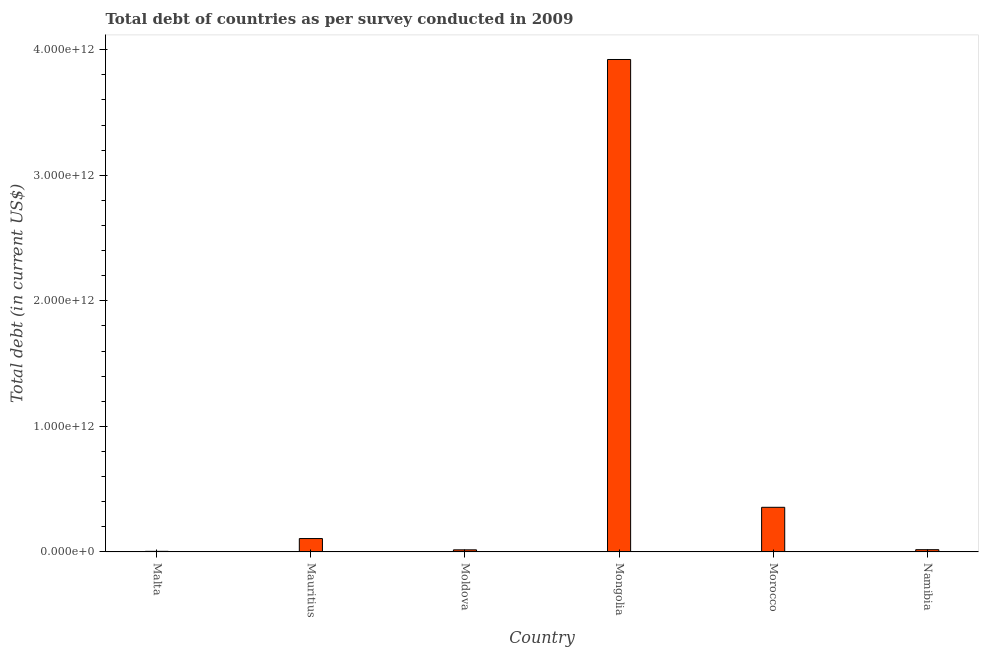What is the title of the graph?
Offer a terse response. Total debt of countries as per survey conducted in 2009. What is the label or title of the Y-axis?
Offer a terse response. Total debt (in current US$). What is the total debt in Morocco?
Keep it short and to the point. 3.56e+11. Across all countries, what is the maximum total debt?
Provide a succinct answer. 3.92e+12. Across all countries, what is the minimum total debt?
Provide a short and direct response. 4.78e+09. In which country was the total debt maximum?
Ensure brevity in your answer.  Mongolia. In which country was the total debt minimum?
Provide a succinct answer. Malta. What is the sum of the total debt?
Your response must be concise. 4.42e+12. What is the difference between the total debt in Malta and Mauritius?
Offer a terse response. -1.02e+11. What is the average total debt per country?
Ensure brevity in your answer.  7.37e+11. What is the median total debt?
Provide a succinct answer. 6.23e+1. In how many countries, is the total debt greater than 2200000000000 US$?
Make the answer very short. 1. What is the ratio of the total debt in Mauritius to that in Mongolia?
Offer a terse response. 0.03. Is the difference between the total debt in Mauritius and Namibia greater than the difference between any two countries?
Your answer should be compact. No. What is the difference between the highest and the second highest total debt?
Your answer should be compact. 3.57e+12. Is the sum of the total debt in Malta and Moldova greater than the maximum total debt across all countries?
Offer a terse response. No. What is the difference between the highest and the lowest total debt?
Provide a short and direct response. 3.92e+12. How many bars are there?
Provide a short and direct response. 6. How many countries are there in the graph?
Your answer should be very brief. 6. What is the difference between two consecutive major ticks on the Y-axis?
Provide a succinct answer. 1.00e+12. Are the values on the major ticks of Y-axis written in scientific E-notation?
Your answer should be compact. Yes. What is the Total debt (in current US$) of Malta?
Make the answer very short. 4.78e+09. What is the Total debt (in current US$) in Mauritius?
Make the answer very short. 1.07e+11. What is the Total debt (in current US$) of Moldova?
Ensure brevity in your answer.  1.67e+1. What is the Total debt (in current US$) of Mongolia?
Ensure brevity in your answer.  3.92e+12. What is the Total debt (in current US$) of Morocco?
Ensure brevity in your answer.  3.56e+11. What is the Total debt (in current US$) in Namibia?
Your response must be concise. 1.79e+1. What is the difference between the Total debt (in current US$) in Malta and Mauritius?
Make the answer very short. -1.02e+11. What is the difference between the Total debt (in current US$) in Malta and Moldova?
Offer a terse response. -1.19e+1. What is the difference between the Total debt (in current US$) in Malta and Mongolia?
Give a very brief answer. -3.92e+12. What is the difference between the Total debt (in current US$) in Malta and Morocco?
Your answer should be compact. -3.51e+11. What is the difference between the Total debt (in current US$) in Malta and Namibia?
Your answer should be compact. -1.32e+1. What is the difference between the Total debt (in current US$) in Mauritius and Moldova?
Keep it short and to the point. 9.00e+1. What is the difference between the Total debt (in current US$) in Mauritius and Mongolia?
Give a very brief answer. -3.82e+12. What is the difference between the Total debt (in current US$) in Mauritius and Morocco?
Ensure brevity in your answer.  -2.49e+11. What is the difference between the Total debt (in current US$) in Mauritius and Namibia?
Provide a short and direct response. 8.87e+1. What is the difference between the Total debt (in current US$) in Moldova and Mongolia?
Your answer should be compact. -3.91e+12. What is the difference between the Total debt (in current US$) in Moldova and Morocco?
Give a very brief answer. -3.39e+11. What is the difference between the Total debt (in current US$) in Moldova and Namibia?
Provide a short and direct response. -1.25e+09. What is the difference between the Total debt (in current US$) in Mongolia and Morocco?
Your answer should be very brief. 3.57e+12. What is the difference between the Total debt (in current US$) in Mongolia and Namibia?
Offer a terse response. 3.90e+12. What is the difference between the Total debt (in current US$) in Morocco and Namibia?
Make the answer very short. 3.38e+11. What is the ratio of the Total debt (in current US$) in Malta to that in Mauritius?
Make the answer very short. 0.04. What is the ratio of the Total debt (in current US$) in Malta to that in Moldova?
Keep it short and to the point. 0.29. What is the ratio of the Total debt (in current US$) in Malta to that in Morocco?
Give a very brief answer. 0.01. What is the ratio of the Total debt (in current US$) in Malta to that in Namibia?
Make the answer very short. 0.27. What is the ratio of the Total debt (in current US$) in Mauritius to that in Moldova?
Your answer should be very brief. 6.39. What is the ratio of the Total debt (in current US$) in Mauritius to that in Mongolia?
Offer a terse response. 0.03. What is the ratio of the Total debt (in current US$) in Mauritius to that in Namibia?
Your answer should be compact. 5.94. What is the ratio of the Total debt (in current US$) in Moldova to that in Mongolia?
Your response must be concise. 0. What is the ratio of the Total debt (in current US$) in Moldova to that in Morocco?
Ensure brevity in your answer.  0.05. What is the ratio of the Total debt (in current US$) in Mongolia to that in Morocco?
Provide a short and direct response. 11.03. What is the ratio of the Total debt (in current US$) in Mongolia to that in Namibia?
Ensure brevity in your answer.  218.56. What is the ratio of the Total debt (in current US$) in Morocco to that in Namibia?
Provide a short and direct response. 19.82. 